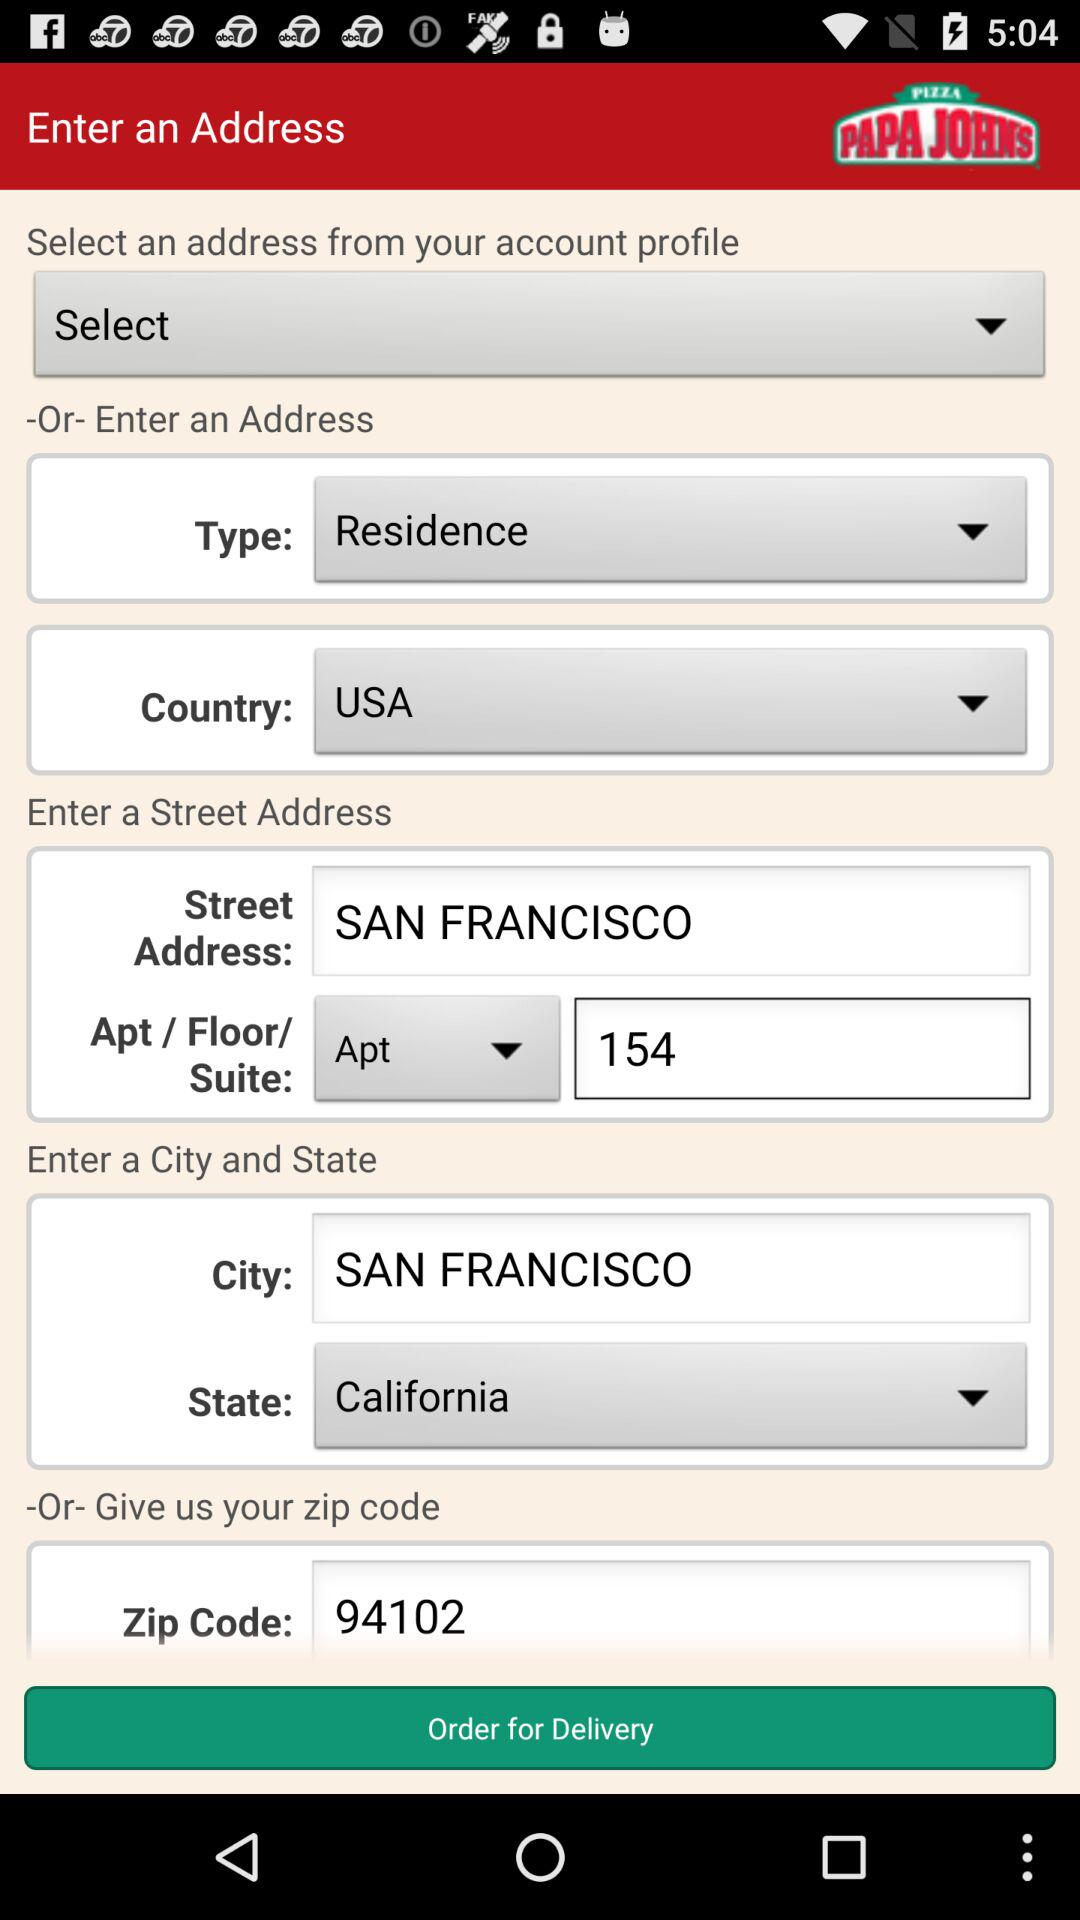What is the "Zip Code"? The zip code is 94102. 